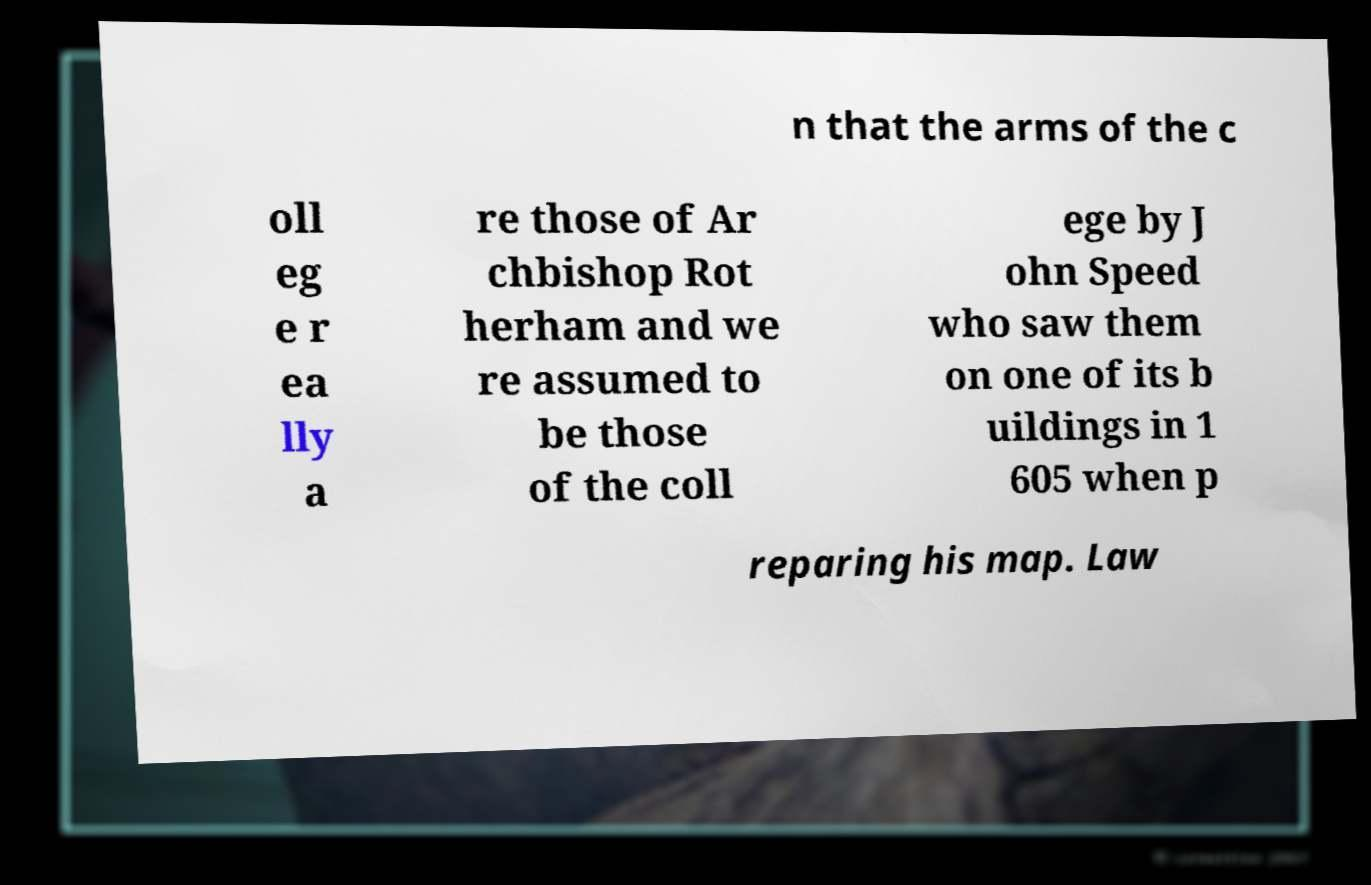Please read and relay the text visible in this image. What does it say? n that the arms of the c oll eg e r ea lly a re those of Ar chbishop Rot herham and we re assumed to be those of the coll ege by J ohn Speed who saw them on one of its b uildings in 1 605 when p reparing his map. Law 